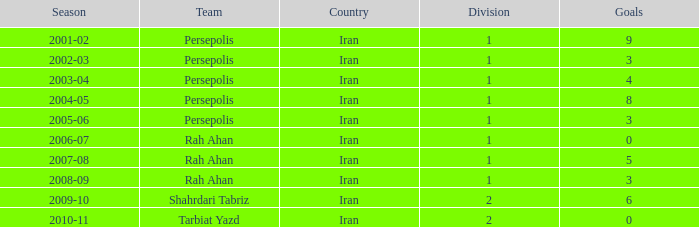What is the sum of Goals, when Season is "2005-06", and when Division is less than 1? None. 